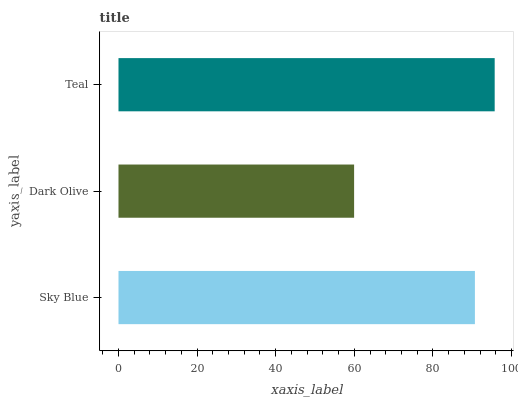Is Dark Olive the minimum?
Answer yes or no. Yes. Is Teal the maximum?
Answer yes or no. Yes. Is Teal the minimum?
Answer yes or no. No. Is Dark Olive the maximum?
Answer yes or no. No. Is Teal greater than Dark Olive?
Answer yes or no. Yes. Is Dark Olive less than Teal?
Answer yes or no. Yes. Is Dark Olive greater than Teal?
Answer yes or no. No. Is Teal less than Dark Olive?
Answer yes or no. No. Is Sky Blue the high median?
Answer yes or no. Yes. Is Sky Blue the low median?
Answer yes or no. Yes. Is Teal the high median?
Answer yes or no. No. Is Dark Olive the low median?
Answer yes or no. No. 